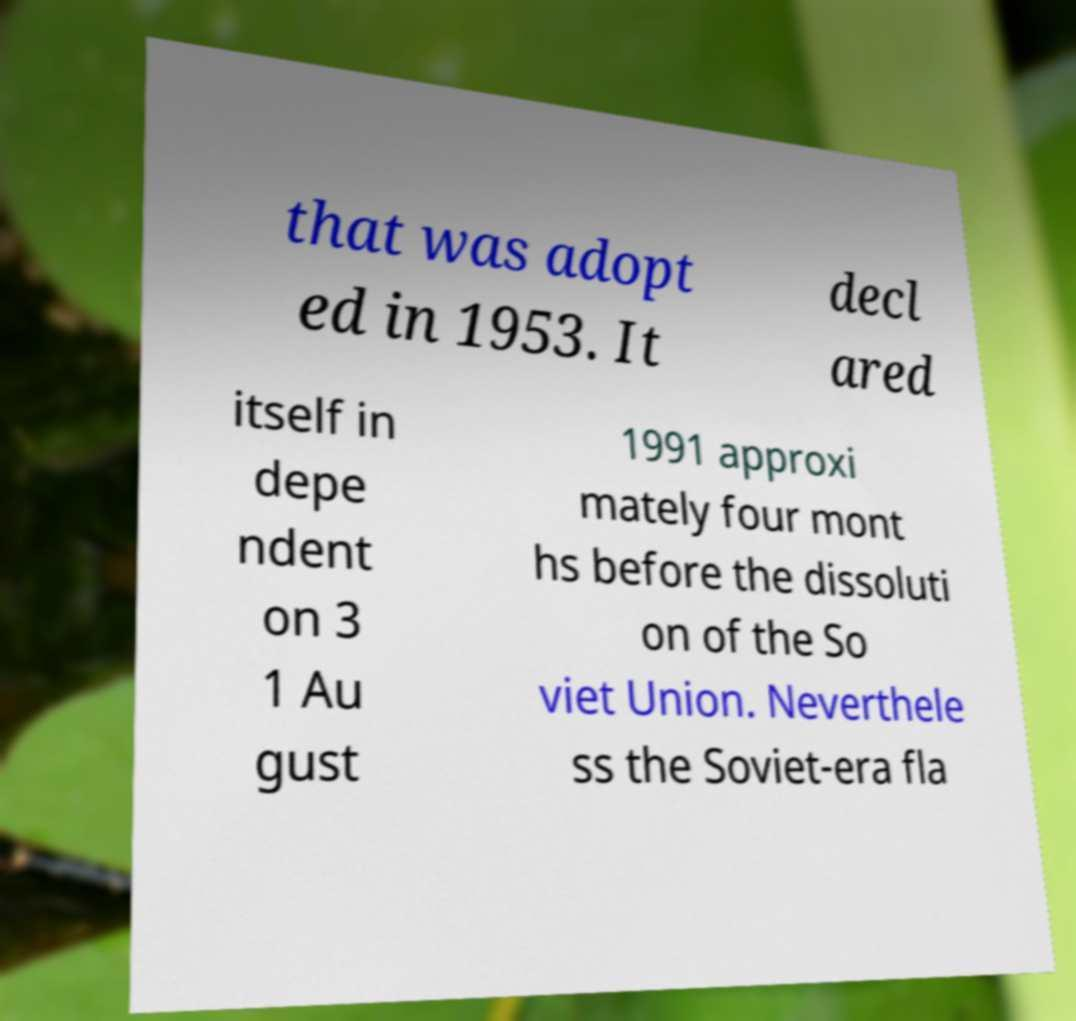Please read and relay the text visible in this image. What does it say? that was adopt ed in 1953. It decl ared itself in depe ndent on 3 1 Au gust 1991 approxi mately four mont hs before the dissoluti on of the So viet Union. Neverthele ss the Soviet-era fla 